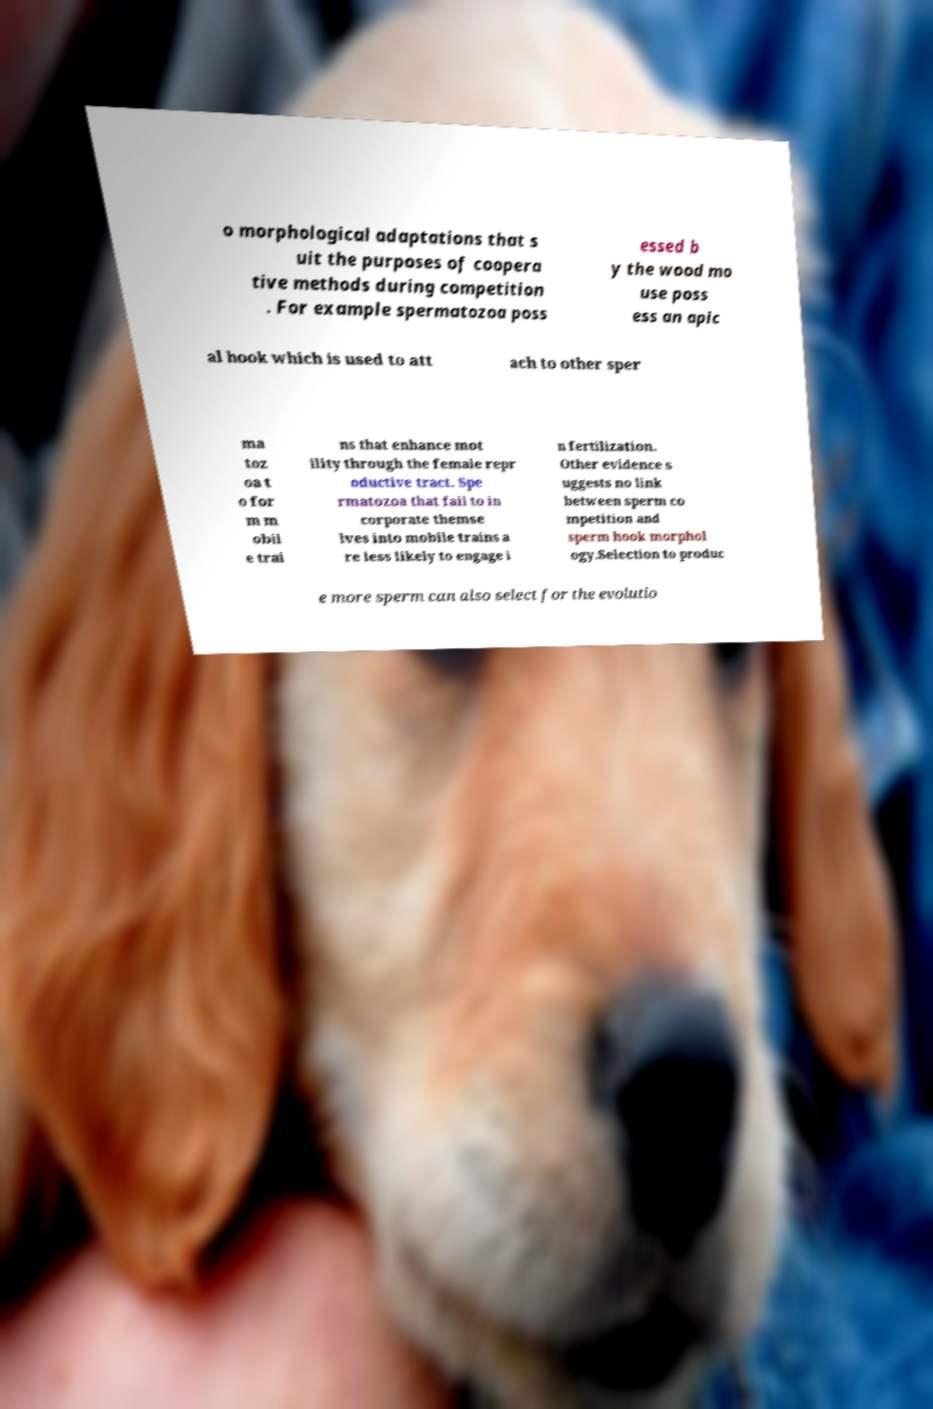There's text embedded in this image that I need extracted. Can you transcribe it verbatim? o morphological adaptations that s uit the purposes of coopera tive methods during competition . For example spermatozoa poss essed b y the wood mo use poss ess an apic al hook which is used to att ach to other sper ma toz oa t o for m m obil e trai ns that enhance mot ility through the female repr oductive tract. Spe rmatozoa that fail to in corporate themse lves into mobile trains a re less likely to engage i n fertilization. Other evidence s uggests no link between sperm co mpetition and sperm hook morphol ogy.Selection to produc e more sperm can also select for the evolutio 